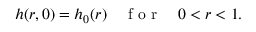<formula> <loc_0><loc_0><loc_500><loc_500>h ( r , 0 ) = h _ { 0 } ( r ) \quad f o r \quad 0 < r < 1 .</formula> 